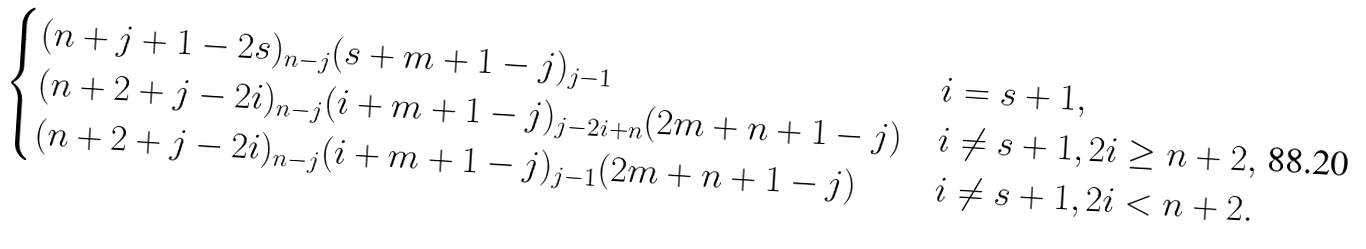Convert formula to latex. <formula><loc_0><loc_0><loc_500><loc_500>\begin{cases} ( n + j + 1 - 2 s ) _ { n - j } ( s + m + 1 - j ) _ { j - 1 } & i = s + 1 , \\ ( n + 2 + j - 2 i ) _ { n - j } ( i + m + 1 - j ) _ { j - 2 i + n } ( 2 m + n + 1 - j ) & i \not = s + 1 , 2 i \geq n + 2 , \\ ( n + 2 + j - 2 i ) _ { n - j } ( i + m + 1 - j ) _ { j - 1 } ( 2 m + n + 1 - j ) & i \not = s + 1 , 2 i < n + 2 . \end{cases}</formula> 